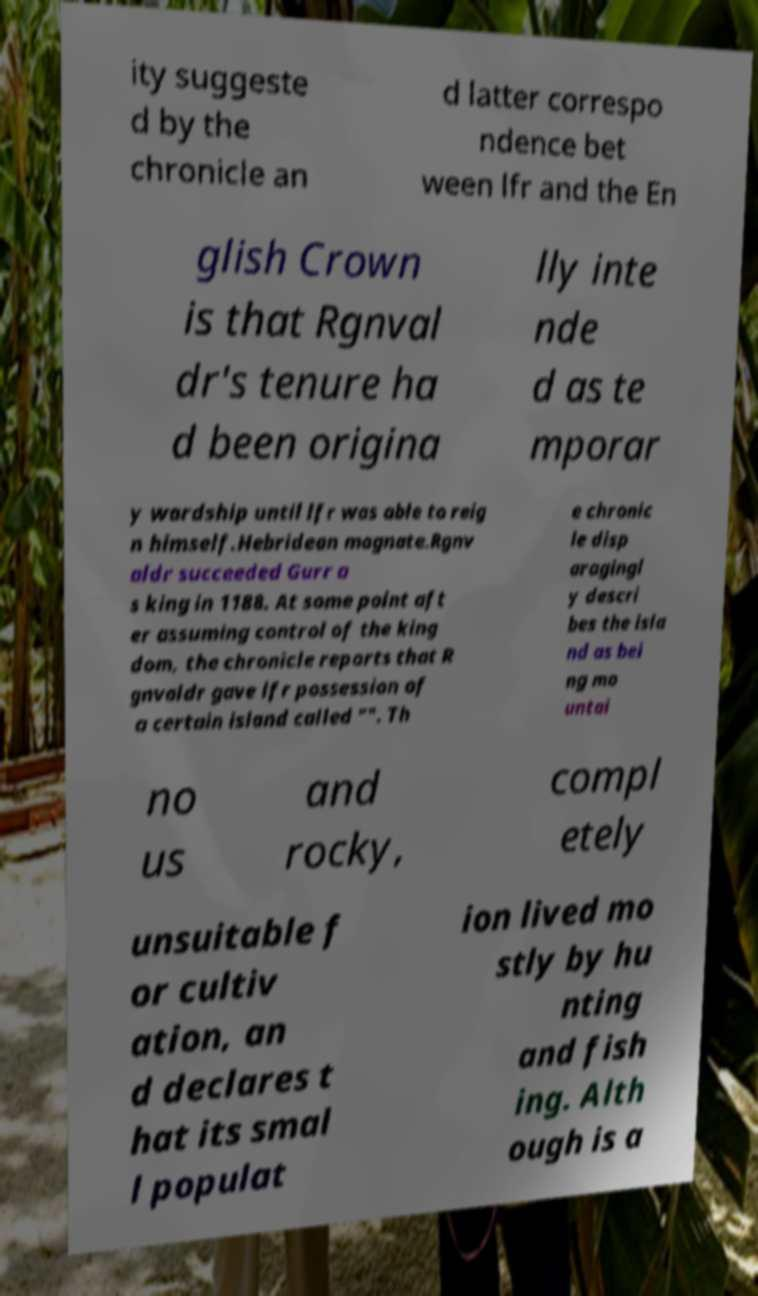Can you read and provide the text displayed in the image?This photo seems to have some interesting text. Can you extract and type it out for me? ity suggeste d by the chronicle an d latter correspo ndence bet ween lfr and the En glish Crown is that Rgnval dr's tenure ha d been origina lly inte nde d as te mporar y wardship until lfr was able to reig n himself.Hebridean magnate.Rgnv aldr succeeded Gurr a s king in 1188. At some point aft er assuming control of the king dom, the chronicle reports that R gnvaldr gave lfr possession of a certain island called "". Th e chronic le disp aragingl y descri bes the isla nd as bei ng mo untai no us and rocky, compl etely unsuitable f or cultiv ation, an d declares t hat its smal l populat ion lived mo stly by hu nting and fish ing. Alth ough is a 